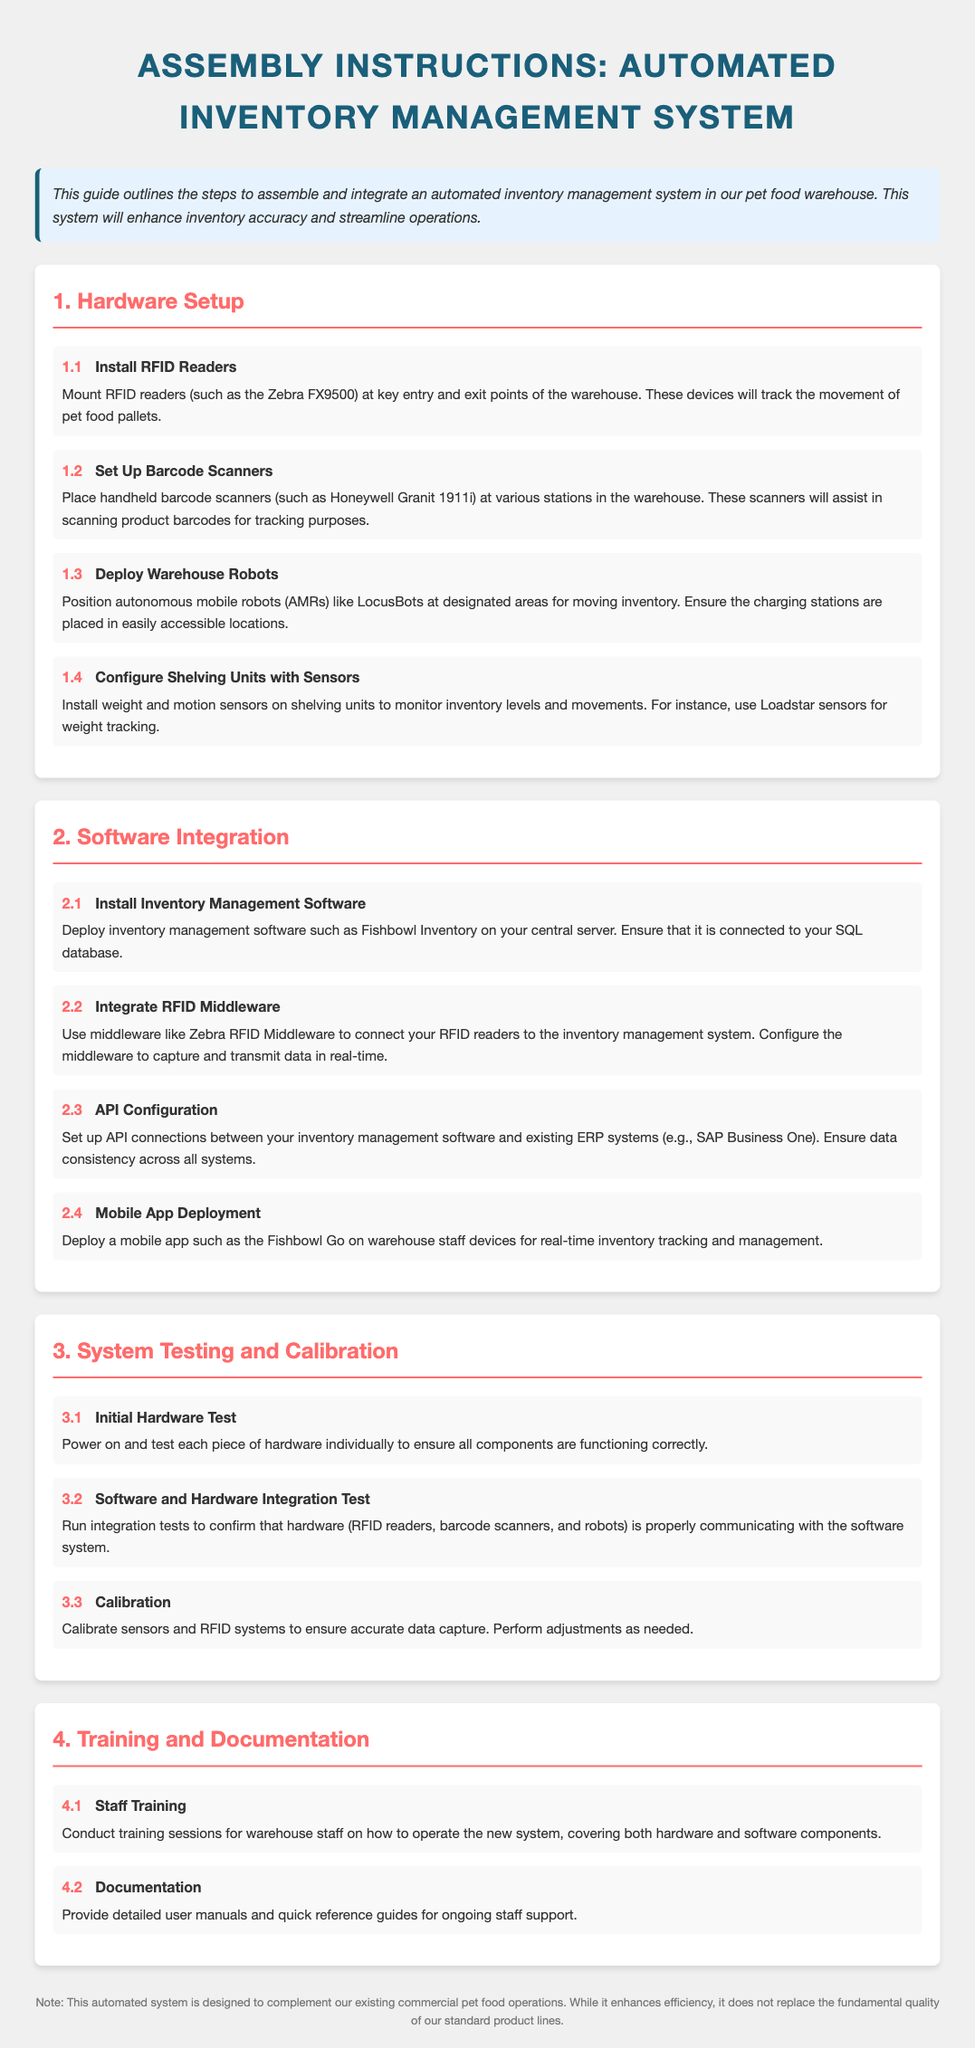what is the title of the document? The title of the document, as indicated at the top, is the main heading that summarizes the subject.
Answer: Assembly Instructions: Automated Inventory Management System who is responsible for operating the new system? The document outlines a step focused on training sessions for personnel.
Answer: warehouse staff what type of hardware is to be installed at the warehouse? The document lists hardware components necessary for the setup.
Answer: RFID Readers how many steps are there in the hardware setup section? This number can be counted from the headers in the hardware setup section.
Answer: 4 which software is suggested for inventory management? This information is found in the second section, focusing on software integration.
Answer: Fishbowl Inventory what is the main purpose of the automated inventory management system? This goal is outlined in the introductory section, explaining the system's intent.
Answer: enhance inventory accuracy what will the RFID readers track? This is a direct mention regarding the function of the RFID readers in the document.
Answer: movement of pet food pallets how many training steps are included in the training section? The number can be determined by examining the training and documentation section.
Answer: 2 what technology is used for moving inventory? This technology is detailed in the hardware setup section as part of the equipment used.
Answer: autonomous mobile robots (AMRs) 